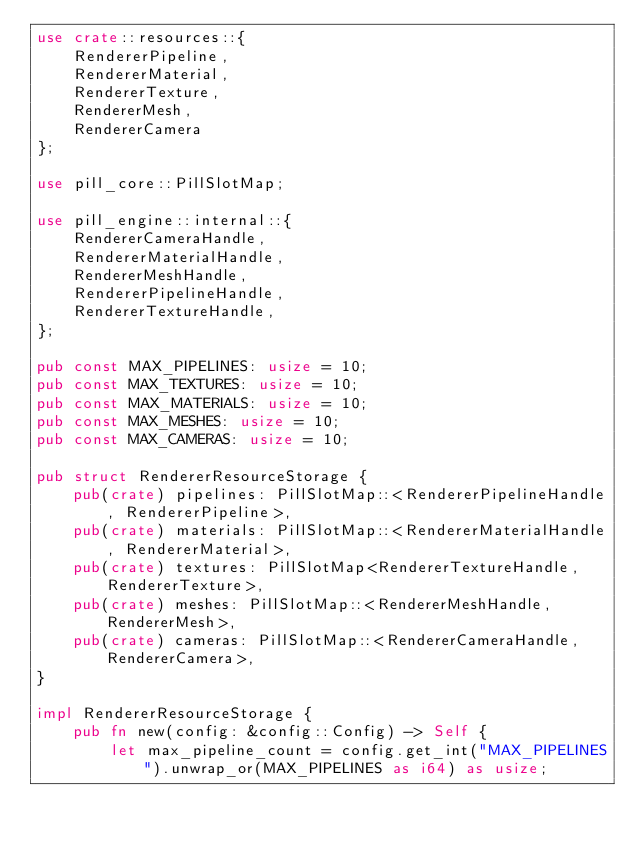Convert code to text. <code><loc_0><loc_0><loc_500><loc_500><_Rust_>use crate::resources::{
    RendererPipeline, 
    RendererMaterial, 
    RendererTexture, 
    RendererMesh, 
    RendererCamera
};

use pill_core::PillSlotMap;

use pill_engine::internal::{
    RendererCameraHandle,
    RendererMaterialHandle,
    RendererMeshHandle,
    RendererPipelineHandle,
    RendererTextureHandle, 
};

pub const MAX_PIPELINES: usize = 10;
pub const MAX_TEXTURES: usize = 10;
pub const MAX_MATERIALS: usize = 10;
pub const MAX_MESHES: usize = 10;
pub const MAX_CAMERAS: usize = 10;

pub struct RendererResourceStorage {
    pub(crate) pipelines: PillSlotMap::<RendererPipelineHandle, RendererPipeline>,
    pub(crate) materials: PillSlotMap::<RendererMaterialHandle, RendererMaterial>,
    pub(crate) textures: PillSlotMap<RendererTextureHandle, RendererTexture>,
    pub(crate) meshes: PillSlotMap::<RendererMeshHandle, RendererMesh>,
    pub(crate) cameras: PillSlotMap::<RendererCameraHandle, RendererCamera>,
}

impl RendererResourceStorage {
    pub fn new(config: &config::Config) -> Self {
        let max_pipeline_count = config.get_int("MAX_PIPELINES").unwrap_or(MAX_PIPELINES as i64) as usize;</code> 